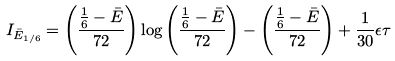Convert formula to latex. <formula><loc_0><loc_0><loc_500><loc_500>I _ { { \bar { E } } _ { 1 / 6 } } = \left ( \frac { \frac { 1 } { 6 } - \bar { E } } { 7 2 } \right ) \log \left ( \frac { \frac { 1 } { 6 } - \bar { E } } { 7 2 } \right ) - \left ( \frac { \frac { 1 } { 6 } - \bar { E } } { 7 2 } \right ) + \frac { 1 } { 3 0 } \epsilon \tau</formula> 